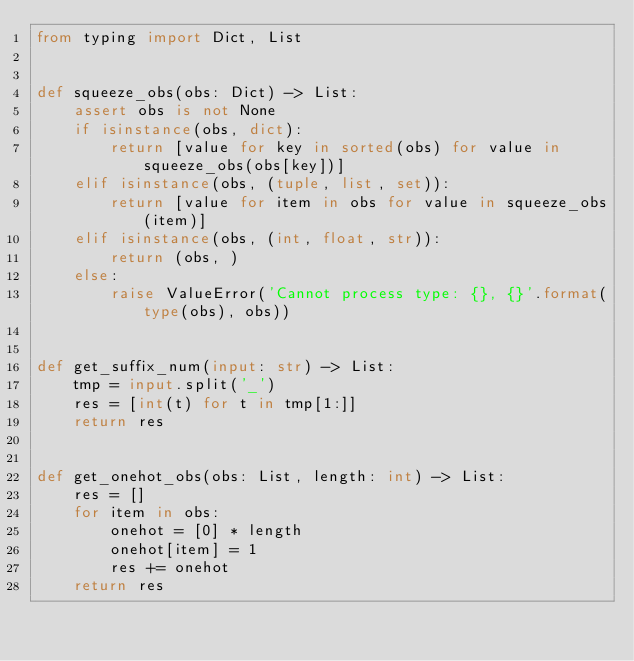<code> <loc_0><loc_0><loc_500><loc_500><_Python_>from typing import Dict, List


def squeeze_obs(obs: Dict) -> List:
    assert obs is not None
    if isinstance(obs, dict):
        return [value for key in sorted(obs) for value in squeeze_obs(obs[key])]
    elif isinstance(obs, (tuple, list, set)):
        return [value for item in obs for value in squeeze_obs(item)]
    elif isinstance(obs, (int, float, str)):
        return (obs, )
    else:
        raise ValueError('Cannot process type: {}, {}'.format(type(obs), obs))


def get_suffix_num(input: str) -> List:
    tmp = input.split('_')
    res = [int(t) for t in tmp[1:]]
    return res


def get_onehot_obs(obs: List, length: int) -> List:
    res = []
    for item in obs:
        onehot = [0] * length
        onehot[item] = 1
        res += onehot
    return res
</code> 